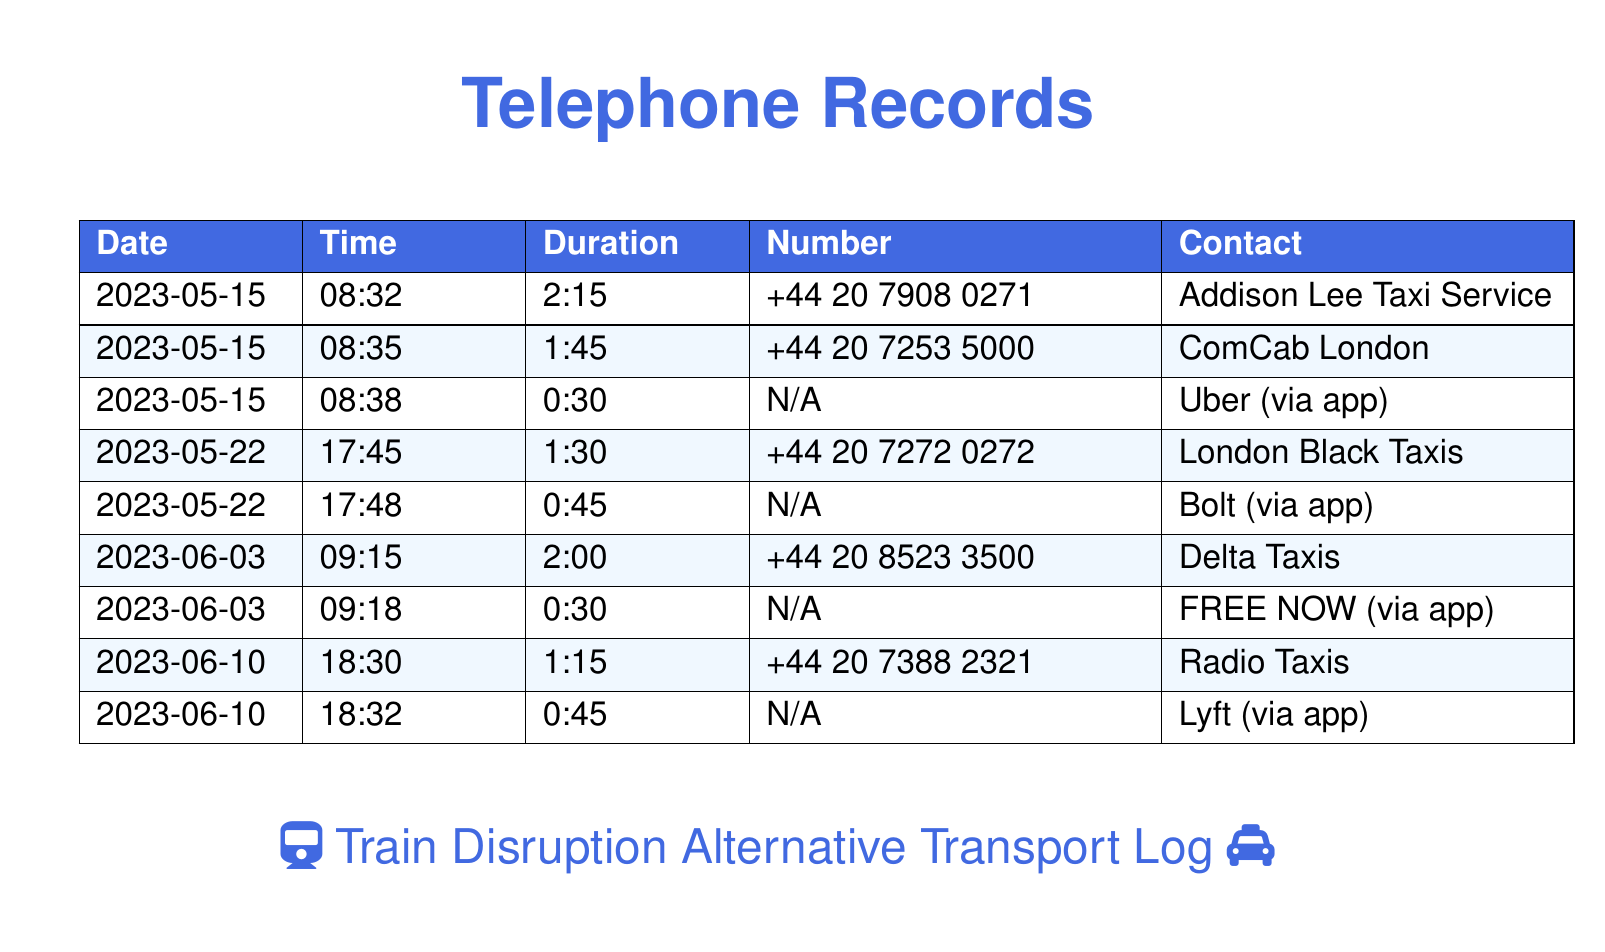What is the first contact listed? The first contact listed in the telephone records is the Addison Lee Taxi Service.
Answer: Addison Lee Taxi Service On what date was the last call made? The last call in the records was made on June 10, 2023.
Answer: 2023-06-10 How long was the call to ComCab London? The duration of the call to ComCab London was 1 minute and 45 seconds.
Answer: 1:45 Which ride-sharing app was used on June 3, 2023? The ride-sharing app used on June 3, 2023, was FREE NOW.
Answer: FREE NOW What time did the caller contact Delta Taxis? The caller contacted Delta Taxis at 09:15.
Answer: 09:15 How many calls were made to ride-sharing apps? There were three calls made to ride-sharing apps.
Answer: 3 What was the duration of the call to London Black Taxis? The duration of the call to London Black Taxis was 1 minute and 30 seconds.
Answer: 1:30 Which taxi service was contacted at 18:30 on June 10? The taxi service contacted at 18:30 on June 10 was Radio Taxis.
Answer: Radio Taxis 